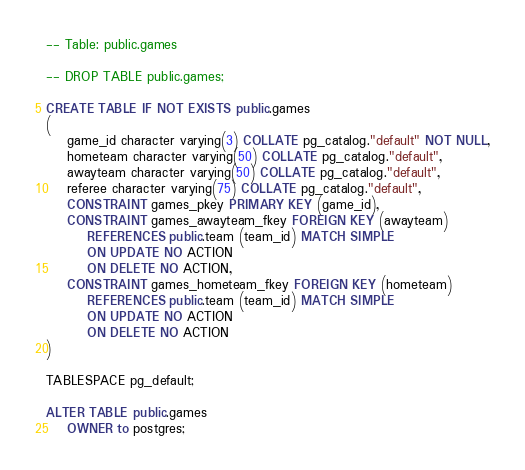<code> <loc_0><loc_0><loc_500><loc_500><_SQL_>-- Table: public.games

-- DROP TABLE public.games;

CREATE TABLE IF NOT EXISTS public.games
(
    game_id character varying(3) COLLATE pg_catalog."default" NOT NULL,
    hometeam character varying(50) COLLATE pg_catalog."default",
    awayteam character varying(50) COLLATE pg_catalog."default",
    referee character varying(75) COLLATE pg_catalog."default",
    CONSTRAINT games_pkey PRIMARY KEY (game_id),
    CONSTRAINT games_awayteam_fkey FOREIGN KEY (awayteam)
        REFERENCES public.team (team_id) MATCH SIMPLE
        ON UPDATE NO ACTION
        ON DELETE NO ACTION,
    CONSTRAINT games_hometeam_fkey FOREIGN KEY (hometeam)
        REFERENCES public.team (team_id) MATCH SIMPLE
        ON UPDATE NO ACTION
        ON DELETE NO ACTION
)

TABLESPACE pg_default;

ALTER TABLE public.games
    OWNER to postgres;
</code> 